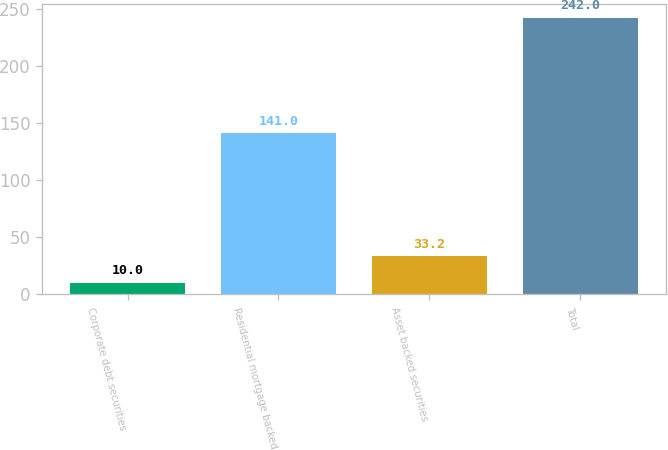Convert chart. <chart><loc_0><loc_0><loc_500><loc_500><bar_chart><fcel>Corporate debt securities<fcel>Residential mortgage backed<fcel>Asset backed securities<fcel>Total<nl><fcel>10<fcel>141<fcel>33.2<fcel>242<nl></chart> 